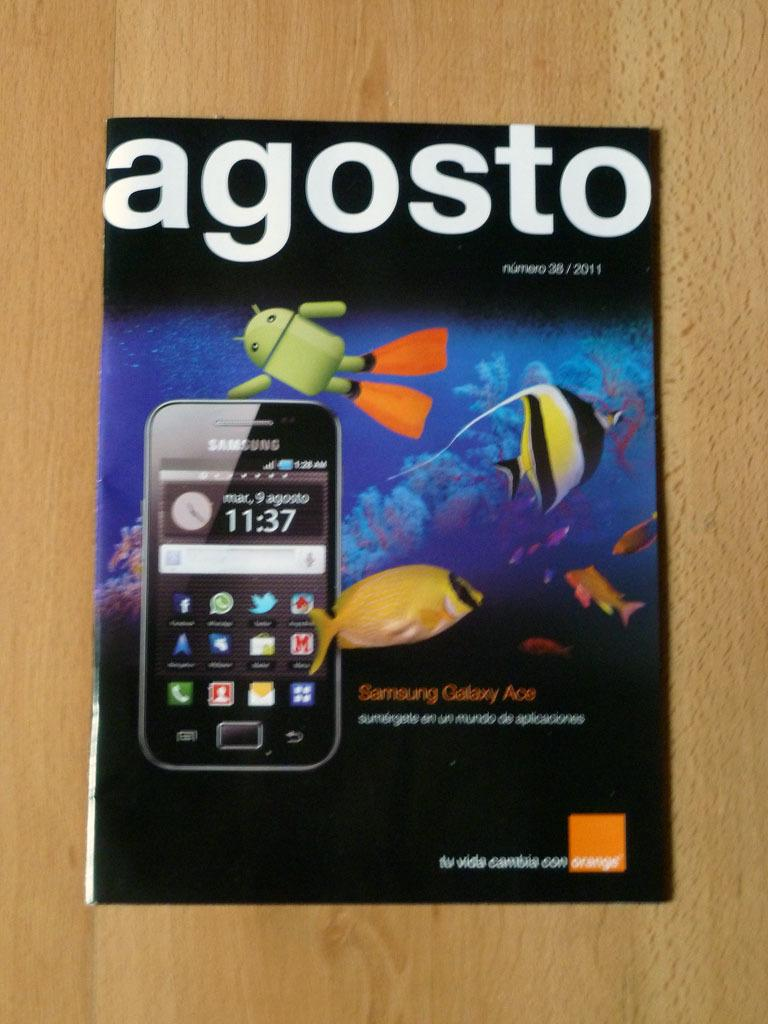<image>
Present a compact description of the photo's key features. An Agosto magazine with a Samsung phone on the cover. 